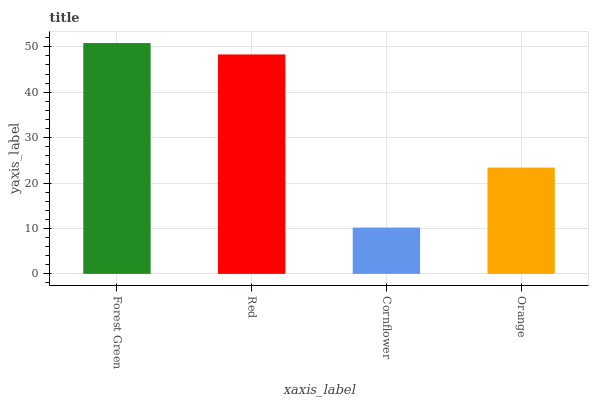Is Cornflower the minimum?
Answer yes or no. Yes. Is Forest Green the maximum?
Answer yes or no. Yes. Is Red the minimum?
Answer yes or no. No. Is Red the maximum?
Answer yes or no. No. Is Forest Green greater than Red?
Answer yes or no. Yes. Is Red less than Forest Green?
Answer yes or no. Yes. Is Red greater than Forest Green?
Answer yes or no. No. Is Forest Green less than Red?
Answer yes or no. No. Is Red the high median?
Answer yes or no. Yes. Is Orange the low median?
Answer yes or no. Yes. Is Forest Green the high median?
Answer yes or no. No. Is Red the low median?
Answer yes or no. No. 